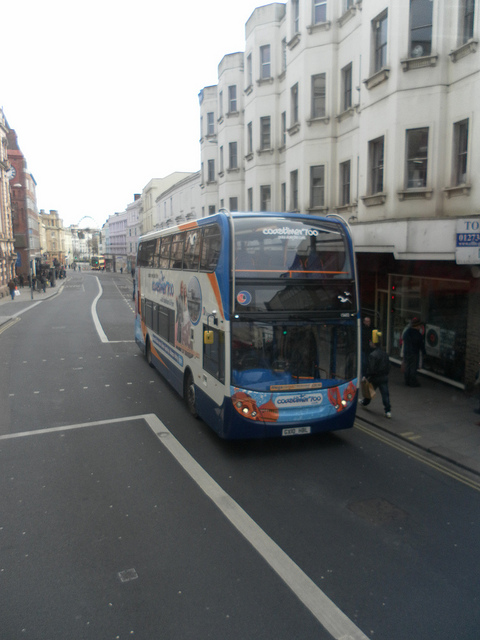<image>Who own's the picture? I don't know who owns the picture. It could be the photographer, the cameraman or the man. Who own's the picture? I don't know who owns the picture. It could be the photographer or someone else. 